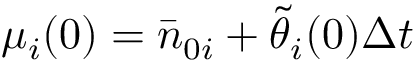<formula> <loc_0><loc_0><loc_500><loc_500>\mu _ { i } ( 0 ) = \bar { n } _ { 0 i } + \tilde { \theta } _ { i } ( 0 ) \Delta t</formula> 